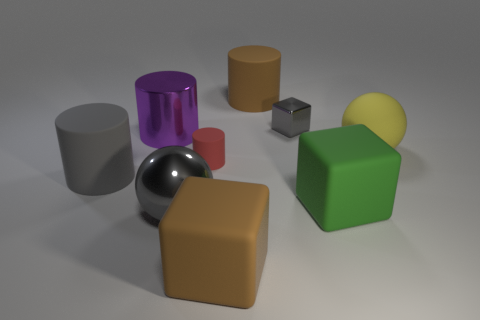Subtract all purple spheres. Subtract all red blocks. How many spheres are left? 2 Add 1 small green rubber things. How many objects exist? 10 Subtract all cylinders. How many objects are left? 5 Add 1 large gray spheres. How many large gray spheres exist? 2 Subtract 1 red cylinders. How many objects are left? 8 Subtract all large objects. Subtract all big brown matte cylinders. How many objects are left? 1 Add 4 gray shiny objects. How many gray shiny objects are left? 6 